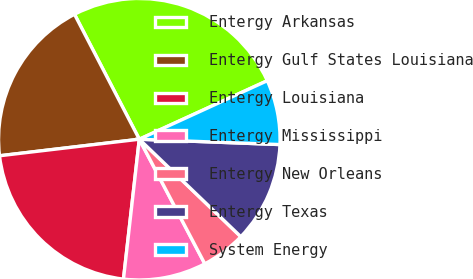Convert chart to OTSL. <chart><loc_0><loc_0><loc_500><loc_500><pie_chart><fcel>Entergy Arkansas<fcel>Entergy Gulf States Louisiana<fcel>Entergy Louisiana<fcel>Entergy Mississippi<fcel>Entergy New Orleans<fcel>Entergy Texas<fcel>System Energy<nl><fcel>25.79%<fcel>19.26%<fcel>21.33%<fcel>9.5%<fcel>5.12%<fcel>11.57%<fcel>7.43%<nl></chart> 